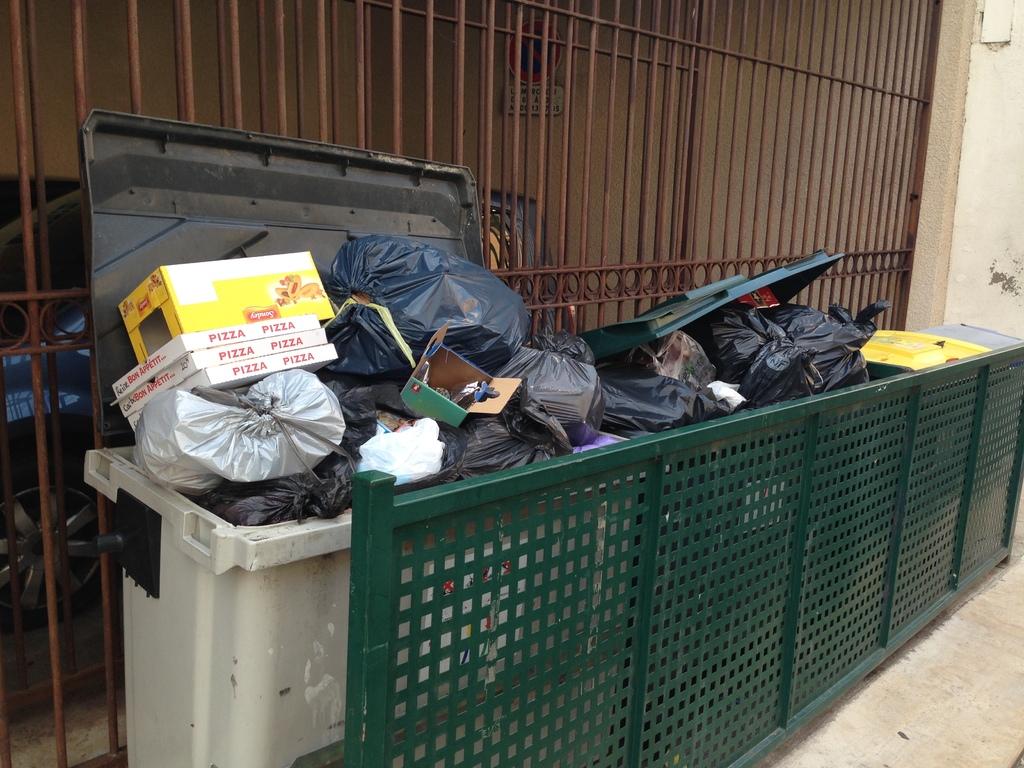What does this shop sell?
Offer a terse response. Unanswerable. What are in the white boxes on the left can?
Ensure brevity in your answer.  Pizza. 